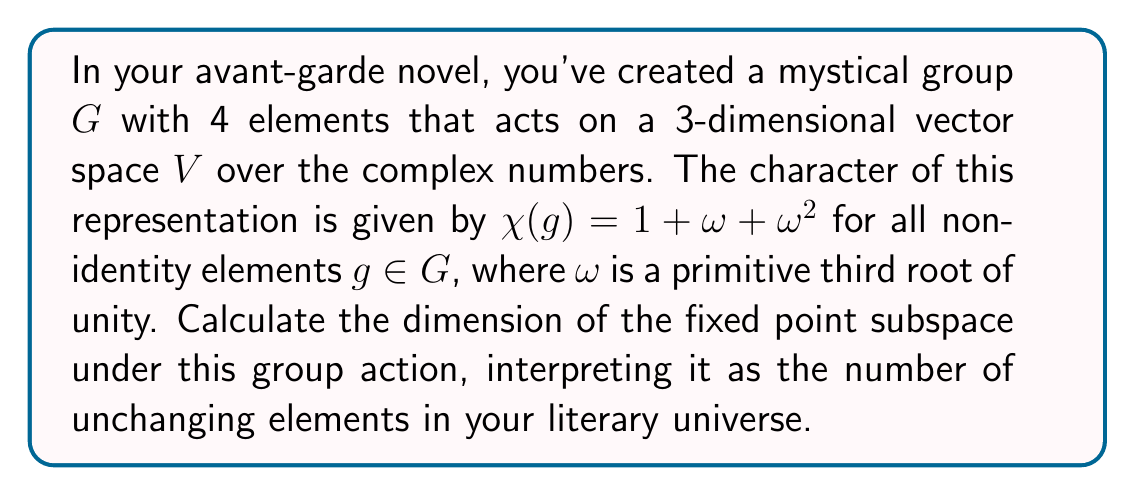Solve this math problem. Let's approach this step-by-step:

1) The dimension of the fixed point subspace can be calculated using the formula:

   $$\dim(V^G) = \frac{1}{|G|} \sum_{g \in G} \chi(g)$$

   where $V^G$ is the fixed point subspace and $|G|$ is the order of the group.

2) We know that $|G| = 4$ and we need to sum $\chi(g)$ for all $g \in G$.

3) For the identity element $e$, $\chi(e)$ is always equal to the dimension of $V$, which is 3.

4) For the other three non-identity elements, $\chi(g) = 1 + \omega + \omega^2$.

5) Therefore, our sum becomes:

   $$\sum_{g \in G} \chi(g) = 3 + 3(1 + \omega + \omega^2)$$

6) Recall that $\omega$ is a primitive third root of unity, which means $1 + \omega + \omega^2 = 0$.

7) Substituting this in:

   $$\sum_{g \in G} \chi(g) = 3 + 3(0) = 3$$

8) Now we can apply our formula:

   $$\dim(V^G) = \frac{1}{|G|} \sum_{g \in G} \chi(g) = \frac{1}{4} \cdot 3 = \frac{3}{4}$$

9) Since dimension must be an integer, we round down to 0.
Answer: 0 